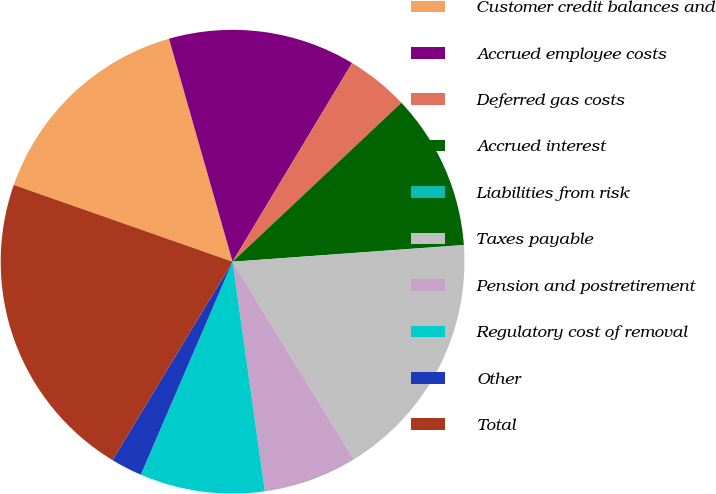Convert chart to OTSL. <chart><loc_0><loc_0><loc_500><loc_500><pie_chart><fcel>Customer credit balances and<fcel>Accrued employee costs<fcel>Deferred gas costs<fcel>Accrued interest<fcel>Liabilities from risk<fcel>Taxes payable<fcel>Pension and postretirement<fcel>Regulatory cost of removal<fcel>Other<fcel>Total<nl><fcel>15.21%<fcel>13.04%<fcel>4.36%<fcel>10.87%<fcel>0.02%<fcel>17.38%<fcel>6.53%<fcel>8.7%<fcel>2.19%<fcel>21.71%<nl></chart> 